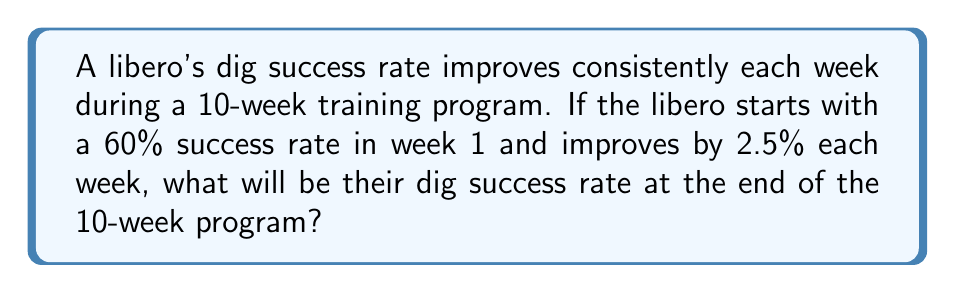Provide a solution to this math problem. To solve this problem, we'll use an arithmetic progression:

1) Initial term (a₁): 60% or 0.60
2) Common difference (d): 2.5% or 0.025
3) Number of terms (n): 10 weeks

The formula for the nth term of an arithmetic progression is:

$$ a_n = a_1 + (n-1)d $$

Where:
$a_n$ is the nth term (final success rate)
$a_1$ is the first term (initial success rate)
$n$ is the number of terms (weeks)
$d$ is the common difference (improvement rate)

Substituting our values:

$$ a_{10} = 0.60 + (10-1)(0.025) $$

$$ a_{10} = 0.60 + (9)(0.025) $$

$$ a_{10} = 0.60 + 0.225 $$

$$ a_{10} = 0.825 $$

Converting to a percentage:

$$ 0.825 \times 100\% = 82.5\% $$

Therefore, the libero's dig success rate at the end of the 10-week program will be 82.5%.
Answer: 82.5% 